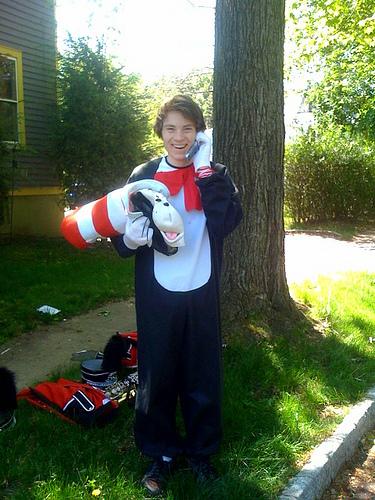What is the person holding?
Keep it brief. Costume. What costume is the boy wearing?
Quick response, please. Cat in hat. What holiday is the boy most likely dressing up for?
Write a very short answer. Halloween. 